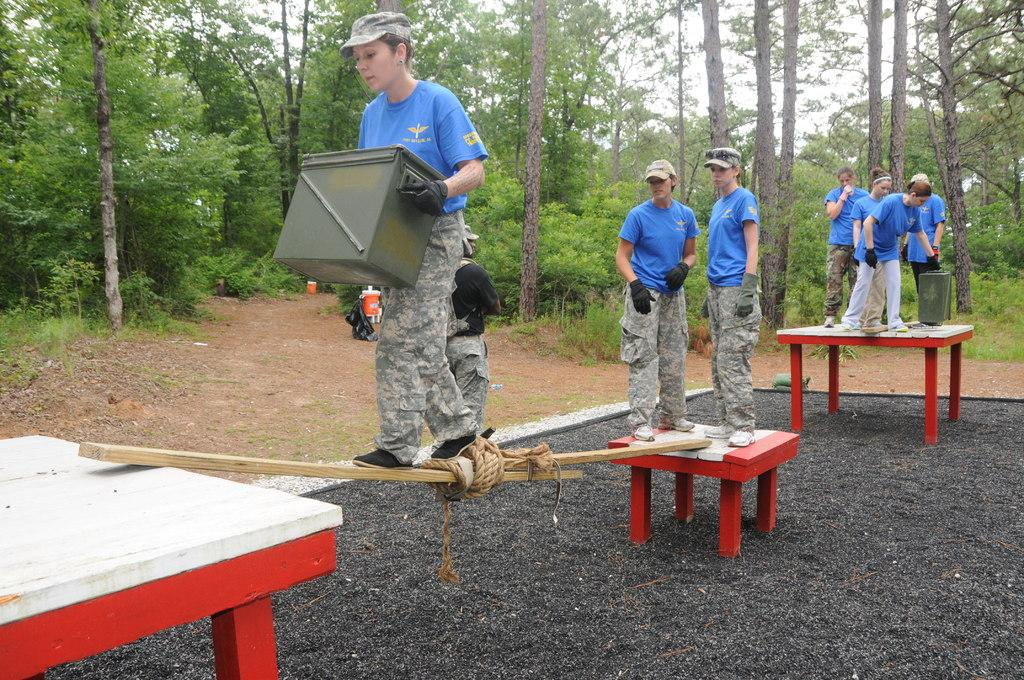What is the main subject of the image? The main subject of the image is a group of girls. What are the girls doing in the image? The girls are standing on tables and moving between tables using sticks. What can be seen in the background of the image? There are trees visible in the image. What type of crayon is the girl holding in the image? There is no crayon present in the image. Can you describe the locket that the girl is wearing in the image? There is no locket visible in the image. 